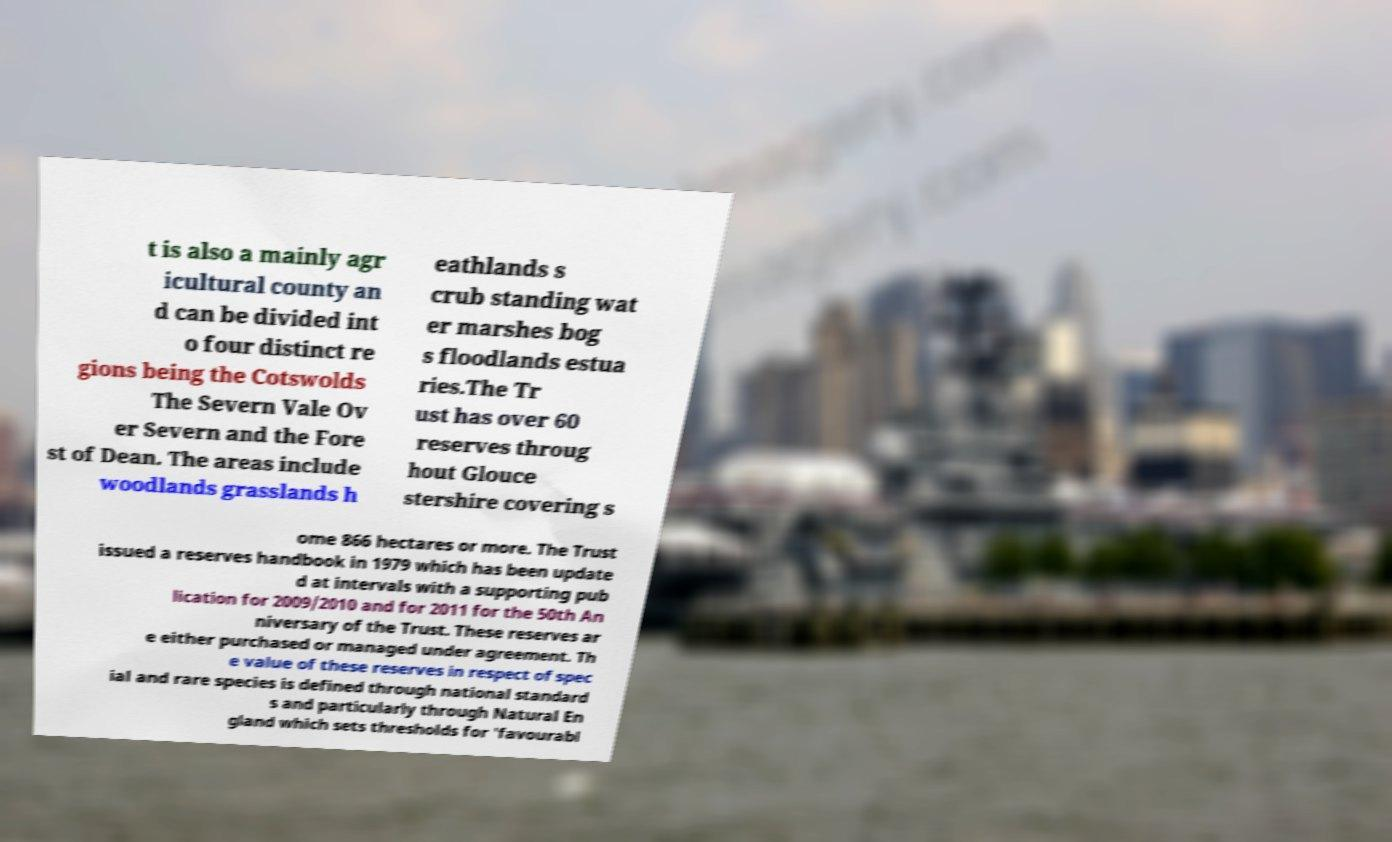There's text embedded in this image that I need extracted. Can you transcribe it verbatim? t is also a mainly agr icultural county an d can be divided int o four distinct re gions being the Cotswolds The Severn Vale Ov er Severn and the Fore st of Dean. The areas include woodlands grasslands h eathlands s crub standing wat er marshes bog s floodlands estua ries.The Tr ust has over 60 reserves throug hout Glouce stershire covering s ome 866 hectares or more. The Trust issued a reserves handbook in 1979 which has been update d at intervals with a supporting pub lication for 2009/2010 and for 2011 for the 50th An niversary of the Trust. These reserves ar e either purchased or managed under agreement. Th e value of these reserves in respect of spec ial and rare species is defined through national standard s and particularly through Natural En gland which sets thresholds for 'favourabl 